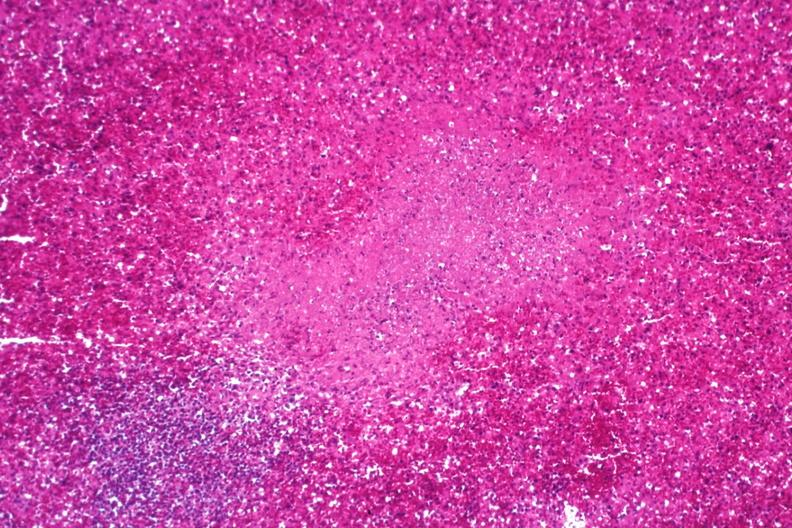s hematologic present?
Answer the question using a single word or phrase. Yes 